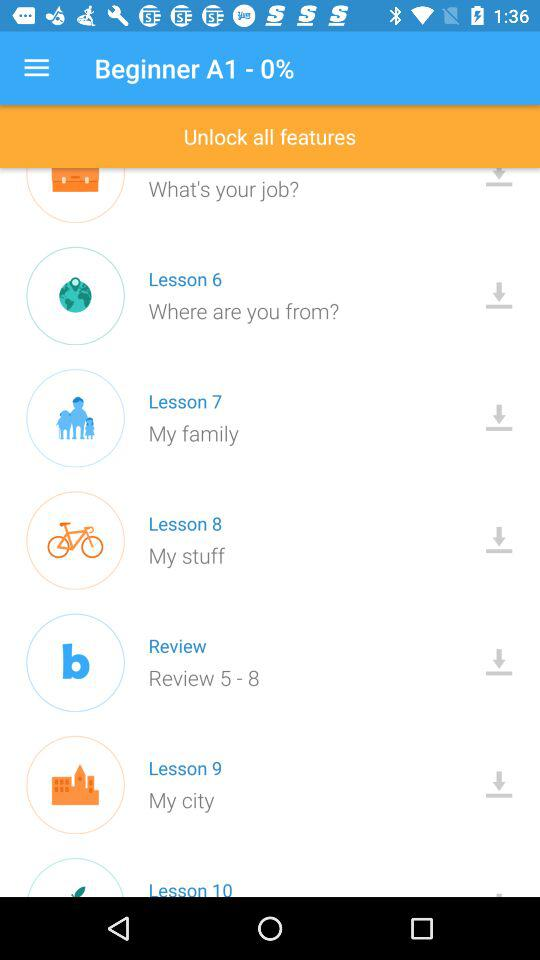How many lessons are there in total?
Answer the question using a single word or phrase. 10 